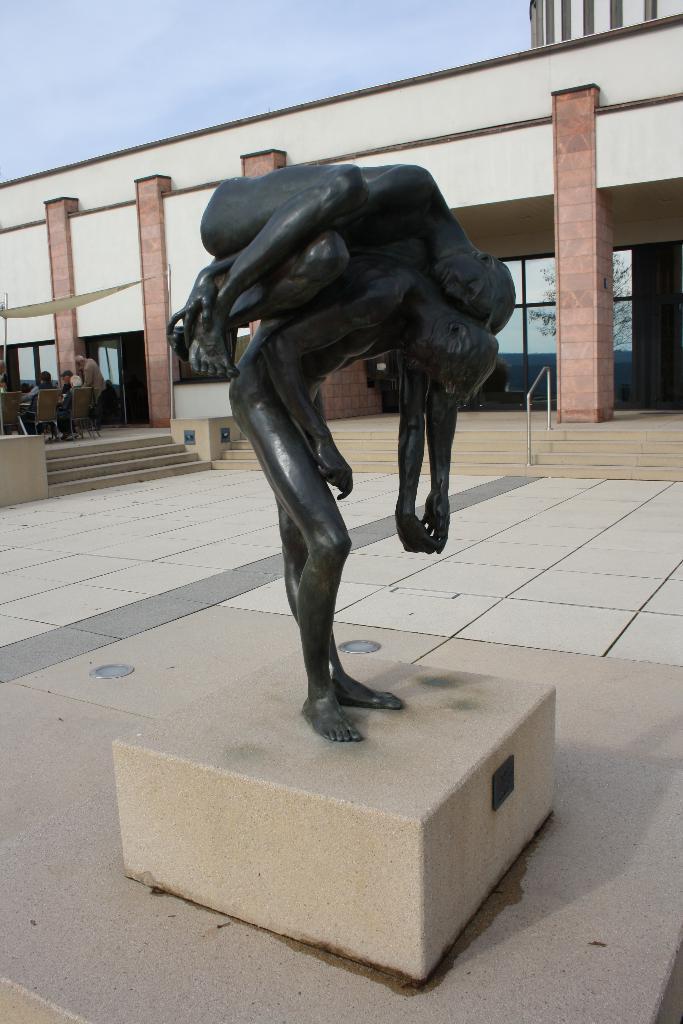Could you give a brief overview of what you see in this image? This is a sculpture, this is a building and a sky. 